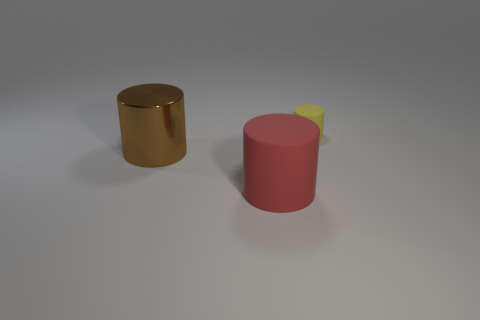What is the shape of the thing that is both right of the big brown metal object and in front of the tiny yellow rubber thing?
Your answer should be compact. Cylinder. There is a big red matte thing; how many small rubber cylinders are on the right side of it?
Provide a short and direct response. 1. Are there any other things that are made of the same material as the big red thing?
Give a very brief answer. Yes. There is a object left of the big red object; is it the same shape as the large red matte object?
Offer a terse response. Yes. There is a rubber cylinder that is to the left of the yellow cylinder; what color is it?
Provide a short and direct response. Red. There is a red object that is the same material as the yellow thing; what is its shape?
Your answer should be very brief. Cylinder. Is there anything else that has the same color as the metallic object?
Provide a succinct answer. No. Are there more things that are on the left side of the tiny cylinder than small yellow things to the left of the red cylinder?
Your response must be concise. Yes. What number of red rubber things have the same size as the brown cylinder?
Provide a short and direct response. 1. Are there fewer matte cylinders that are on the left side of the yellow cylinder than big brown shiny cylinders to the right of the red thing?
Offer a terse response. No. 